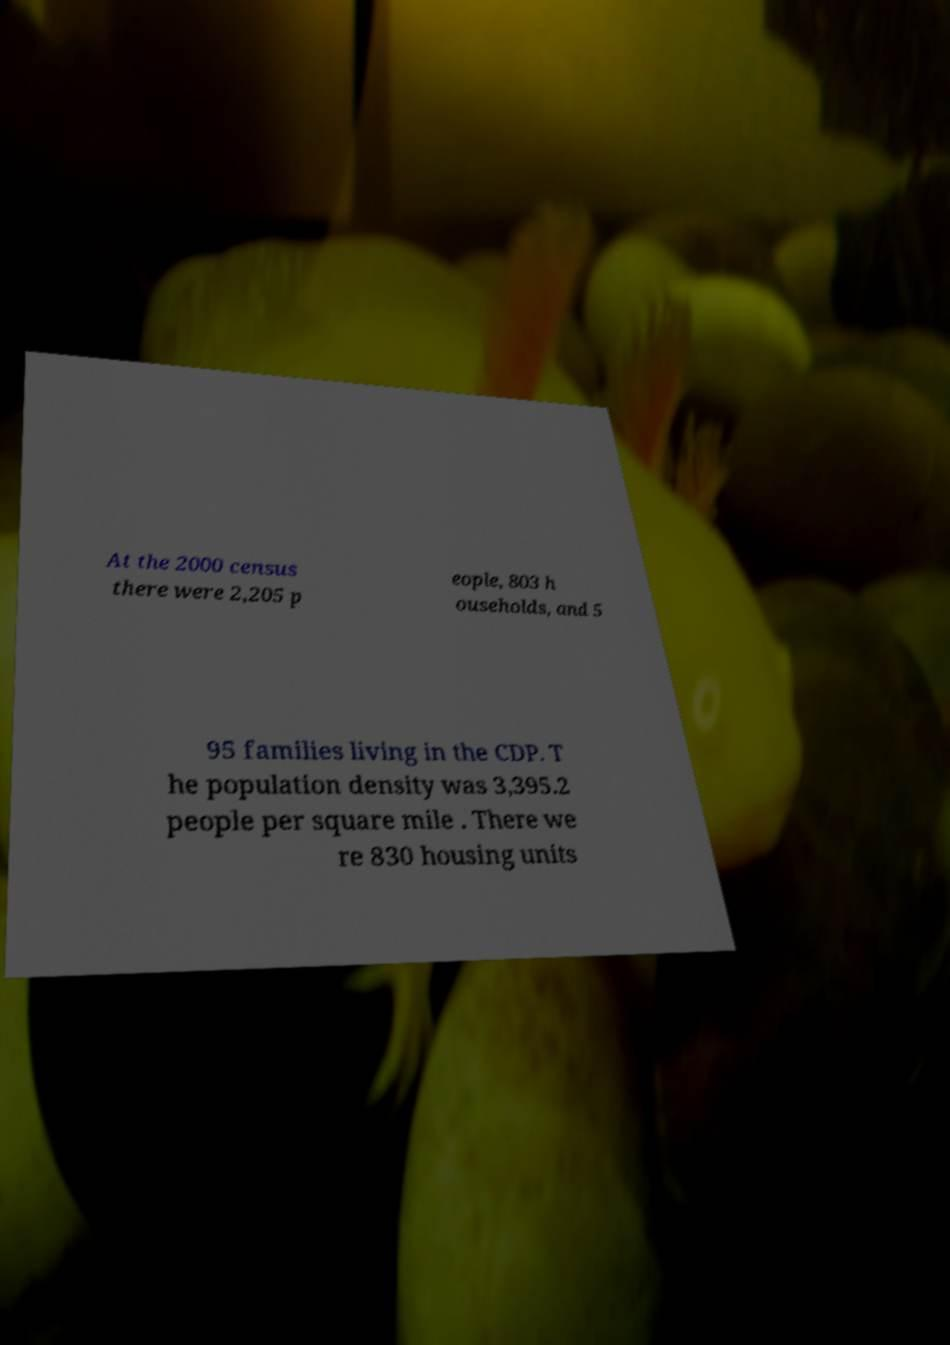There's text embedded in this image that I need extracted. Can you transcribe it verbatim? At the 2000 census there were 2,205 p eople, 803 h ouseholds, and 5 95 families living in the CDP. T he population density was 3,395.2 people per square mile . There we re 830 housing units 